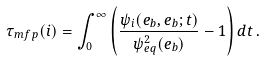Convert formula to latex. <formula><loc_0><loc_0><loc_500><loc_500>\tau _ { m f p } ( i ) = \int _ { 0 } ^ { \infty } \left ( \frac { \psi _ { i } ( e _ { b } , e _ { b } ; t ) } { \psi _ { e q } ^ { 2 } ( e _ { b } ) } - 1 \right ) d t \, .</formula> 